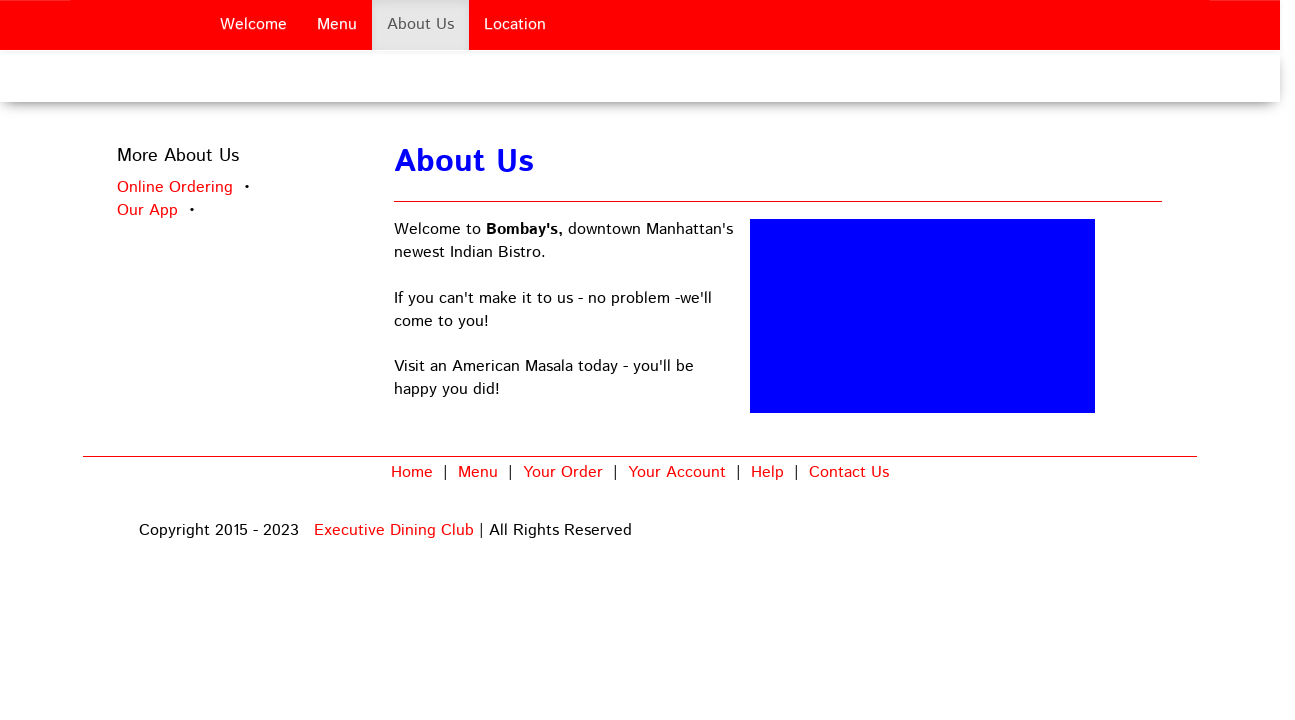Could you detail the process for assembling this website using HTML? To assemble a website like the one shown in the image using HTML, you would begin by defining the structure with HTML. This involves specifying elements such as divs for sections like 'Welcome', 'Menu', 'About Us', and 'Location'. CSS would be used to style these sections, positioning them and adding colors as seen. Next, content would be added within these divs, such as text and links which are also styled using CSS for aesthetics that match the theme of the restaurant. JavaScript could be employed for more interactive elements, such as the drop-down menus or modal windows if any exist. 